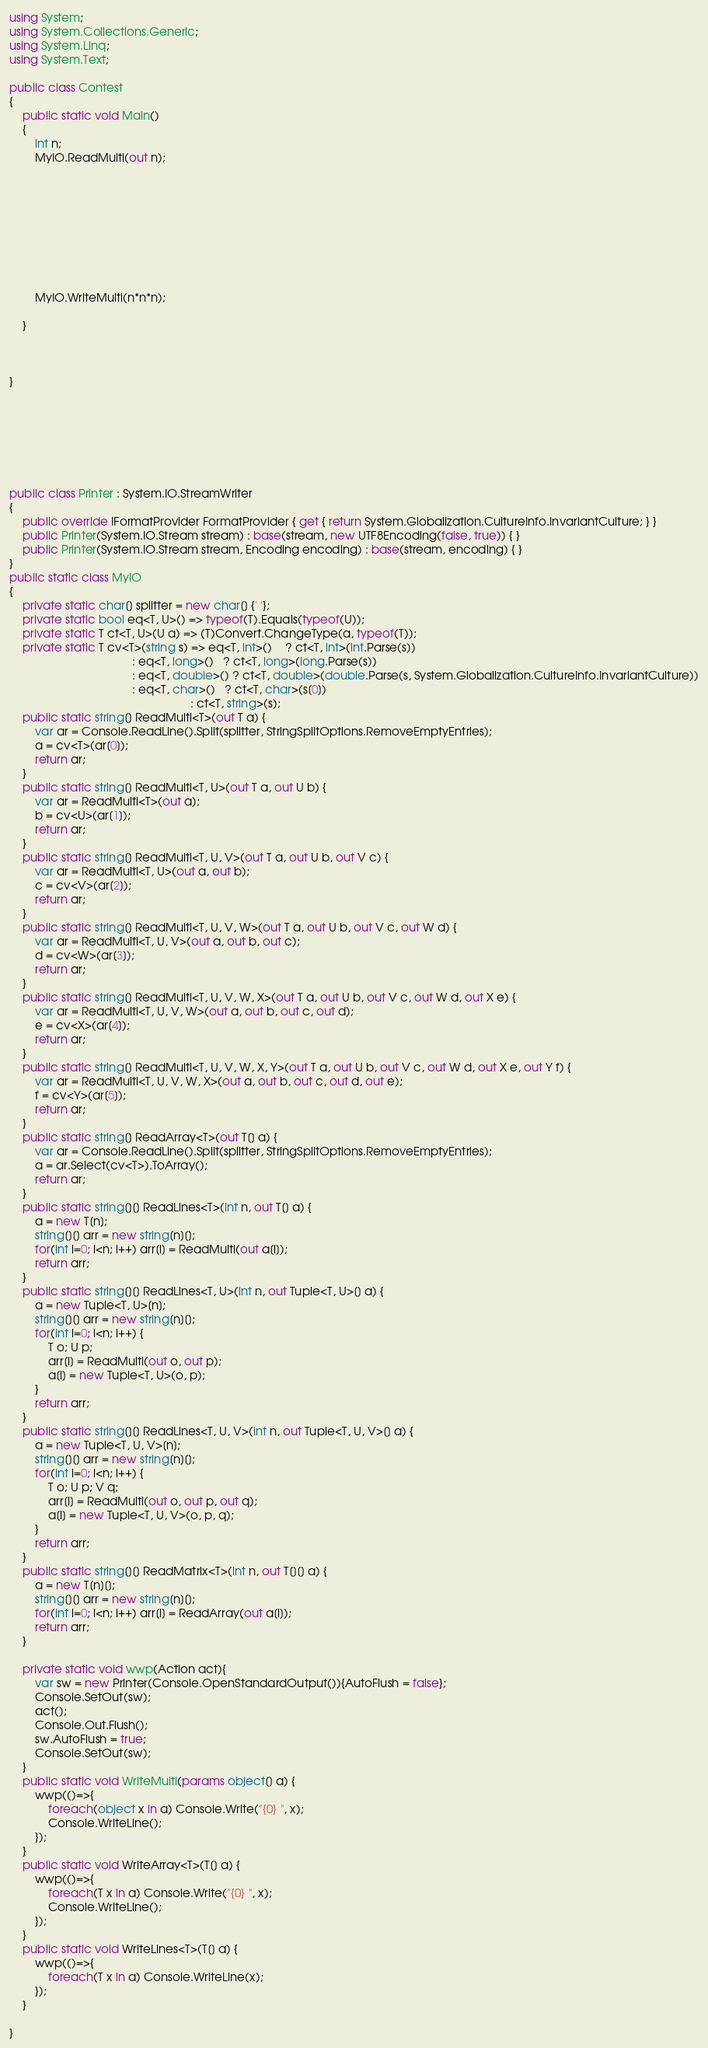Convert code to text. <code><loc_0><loc_0><loc_500><loc_500><_C#_>using System;
using System.Collections.Generic;
using System.Linq;
using System.Text;

public class Contest
{
	public static void Main()
	{
		int n;
		MyIO.ReadMulti(out n);


		






		MyIO.WriteMulti(n*n*n);

	}



}







public class Printer : System.IO.StreamWriter
{
	public override IFormatProvider FormatProvider { get { return System.Globalization.CultureInfo.InvariantCulture; } }
	public Printer(System.IO.Stream stream) : base(stream, new UTF8Encoding(false, true)) { }
	public Printer(System.IO.Stream stream, Encoding encoding) : base(stream, encoding) { }
}
public static class MyIO
{
	private static char[] splitter = new char[] {' '};
	private static bool eq<T, U>() => typeof(T).Equals(typeof(U));
	private static T ct<T, U>(U a) => (T)Convert.ChangeType(a, typeof(T));
	private static T cv<T>(string s) => eq<T, int>()    ? ct<T, int>(int.Parse(s))
	                                  : eq<T, long>()   ? ct<T, long>(long.Parse(s))
	                                  : eq<T, double>() ? ct<T, double>(double.Parse(s, System.Globalization.CultureInfo.InvariantCulture))
	                                  : eq<T, char>()   ? ct<T, char>(s[0])
	                                                    : ct<T, string>(s);				
	public static string[] ReadMulti<T>(out T a) {
		var ar = Console.ReadLine().Split(splitter, StringSplitOptions.RemoveEmptyEntries); 
		a = cv<T>(ar[0]);
		return ar;
	}
	public static string[] ReadMulti<T, U>(out T a, out U b) {
		var ar = ReadMulti<T>(out a); 
        b = cv<U>(ar[1]);
		return ar;
	}
	public static string[] ReadMulti<T, U, V>(out T a, out U b, out V c) {
		var ar = ReadMulti<T, U>(out a, out b); 
        c = cv<V>(ar[2]);
		return ar;
	}
	public static string[] ReadMulti<T, U, V, W>(out T a, out U b, out V c, out W d) {
		var ar = ReadMulti<T, U, V>(out a, out b, out c); 
        d = cv<W>(ar[3]);
		return ar;
	}
	public static string[] ReadMulti<T, U, V, W, X>(out T a, out U b, out V c, out W d, out X e) {
		var ar = ReadMulti<T, U, V, W>(out a, out b, out c, out d); 
        e = cv<X>(ar[4]);
		return ar;
	}
	public static string[] ReadMulti<T, U, V, W, X, Y>(out T a, out U b, out V c, out W d, out X e, out Y f) {
		var ar = ReadMulti<T, U, V, W, X>(out a, out b, out c, out d, out e); 
        f = cv<Y>(ar[5]);
		return ar;
	}
	public static string[] ReadArray<T>(out T[] a) {		
		var ar = Console.ReadLine().Split(splitter, StringSplitOptions.RemoveEmptyEntries);
		a = ar.Select(cv<T>).ToArray();
		return ar;
	}		
	public static string[][] ReadLines<T>(int n, out T[] a) {
		a = new T[n];
		string[][] arr = new string[n][];
		for(int i=0; i<n; i++) arr[i] = ReadMulti(out a[i]);
		return arr;
	}
	public static string[][] ReadLines<T, U>(int n, out Tuple<T, U>[] a) {
		a = new Tuple<T, U>[n];
		string[][] arr = new string[n][];
		for(int i=0; i<n; i++) {
			T o; U p;
			arr[i] = ReadMulti(out o, out p);
			a[i] = new Tuple<T, U>(o, p);
		}
		return arr;
	}
	public static string[][] ReadLines<T, U, V>(int n, out Tuple<T, U, V>[] a) {
		a = new Tuple<T, U, V>[n];
		string[][] arr = new string[n][];
		for(int i=0; i<n; i++) {
			T o; U p; V q;
			arr[i] = ReadMulti(out o, out p, out q);
			a[i] = new Tuple<T, U, V>(o, p, q);
		}
		return arr;
	}
	public static string[][] ReadMatrix<T>(int n, out T[][] a) {
		a = new T[n][];
		string[][] arr = new string[n][];
		for(int i=0; i<n; i++) arr[i] = ReadArray(out a[i]);
		return arr;
	}

	private static void wwp(Action act){
		var sw = new Printer(Console.OpenStandardOutput()){AutoFlush = false};
		Console.SetOut(sw);
		act();
		Console.Out.Flush();
		sw.AutoFlush = true;
		Console.SetOut(sw);
	}
	public static void WriteMulti(params object[] a) {
		wwp(()=>{
			foreach(object x in a) Console.Write("{0} ", x);
			Console.WriteLine();
		});
	}
	public static void WriteArray<T>(T[] a) {
		wwp(()=>{
			foreach(T x in a) Console.Write("{0} ", x);
			Console.WriteLine();
		});
	}
	public static void WriteLines<T>(T[] a) {
		wwp(()=>{
			foreach(T x in a) Console.WriteLine(x);
		});
	}

}



</code> 